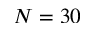Convert formula to latex. <formula><loc_0><loc_0><loc_500><loc_500>N = 3 0</formula> 